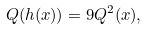Convert formula to latex. <formula><loc_0><loc_0><loc_500><loc_500>Q ( h ( x ) ) = 9 Q ^ { 2 } ( x ) ,</formula> 